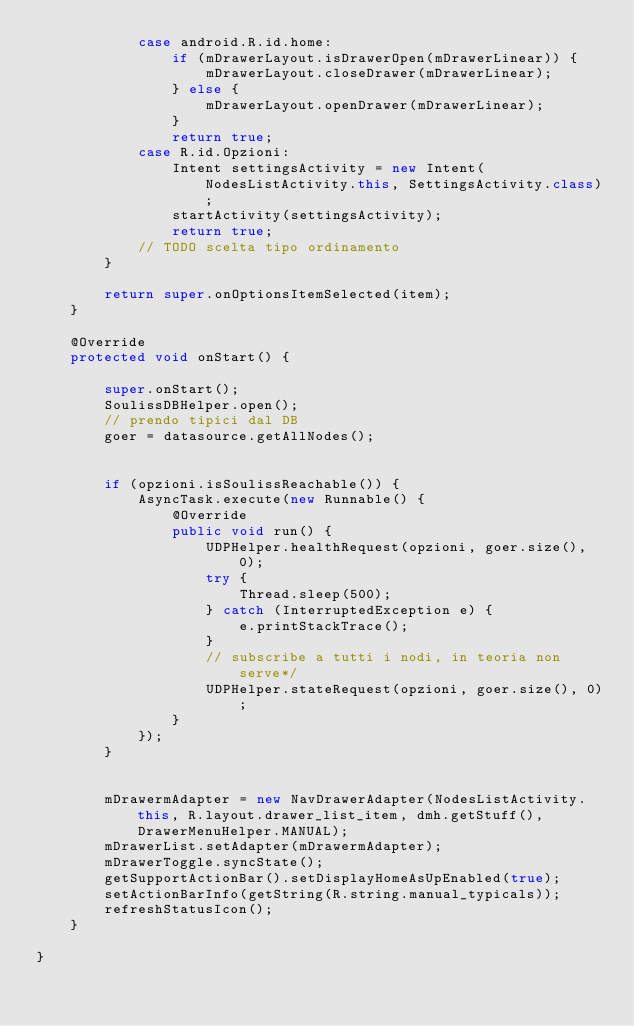Convert code to text. <code><loc_0><loc_0><loc_500><loc_500><_Java_>            case android.R.id.home:
                if (mDrawerLayout.isDrawerOpen(mDrawerLinear)) {
                    mDrawerLayout.closeDrawer(mDrawerLinear);
                } else {
                    mDrawerLayout.openDrawer(mDrawerLinear);
                }
                return true;
            case R.id.Opzioni:
                Intent settingsActivity = new Intent(NodesListActivity.this, SettingsActivity.class);
                startActivity(settingsActivity);
                return true;
            // TODO scelta tipo ordinamento
        }

        return super.onOptionsItemSelected(item);
    }

    @Override
    protected void onStart() {

        super.onStart();
        SoulissDBHelper.open();
        // prendo tipici dal DB
        goer = datasource.getAllNodes();


        if (opzioni.isSoulissReachable()) {
            AsyncTask.execute(new Runnable() {
                @Override
                public void run() {
                    UDPHelper.healthRequest(opzioni, goer.size(), 0);
                    try {
                        Thread.sleep(500);
                    } catch (InterruptedException e) {
                        e.printStackTrace();
                    }
                    // subscribe a tutti i nodi, in teoria non serve*/
                    UDPHelper.stateRequest(opzioni, goer.size(), 0);
                }
            });
        }


        mDrawermAdapter = new NavDrawerAdapter(NodesListActivity.this, R.layout.drawer_list_item, dmh.getStuff(), DrawerMenuHelper.MANUAL);
        mDrawerList.setAdapter(mDrawermAdapter);
        mDrawerToggle.syncState();
        getSupportActionBar().setDisplayHomeAsUpEnabled(true);
        setActionBarInfo(getString(R.string.manual_typicals));
        refreshStatusIcon();
    }

}
</code> 